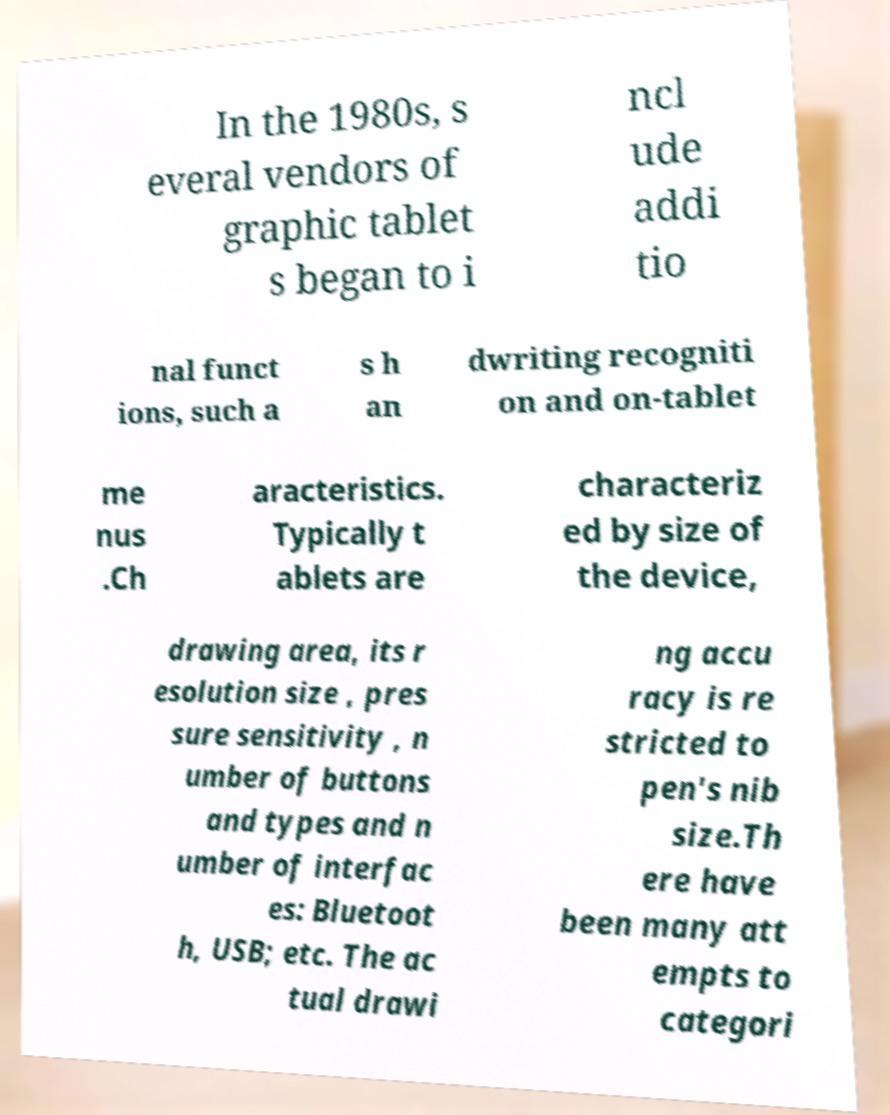Please read and relay the text visible in this image. What does it say? In the 1980s, s everal vendors of graphic tablet s began to i ncl ude addi tio nal funct ions, such a s h an dwriting recogniti on and on-tablet me nus .Ch aracteristics. Typically t ablets are characteriz ed by size of the device, drawing area, its r esolution size , pres sure sensitivity , n umber of buttons and types and n umber of interfac es: Bluetoot h, USB; etc. The ac tual drawi ng accu racy is re stricted to pen's nib size.Th ere have been many att empts to categori 